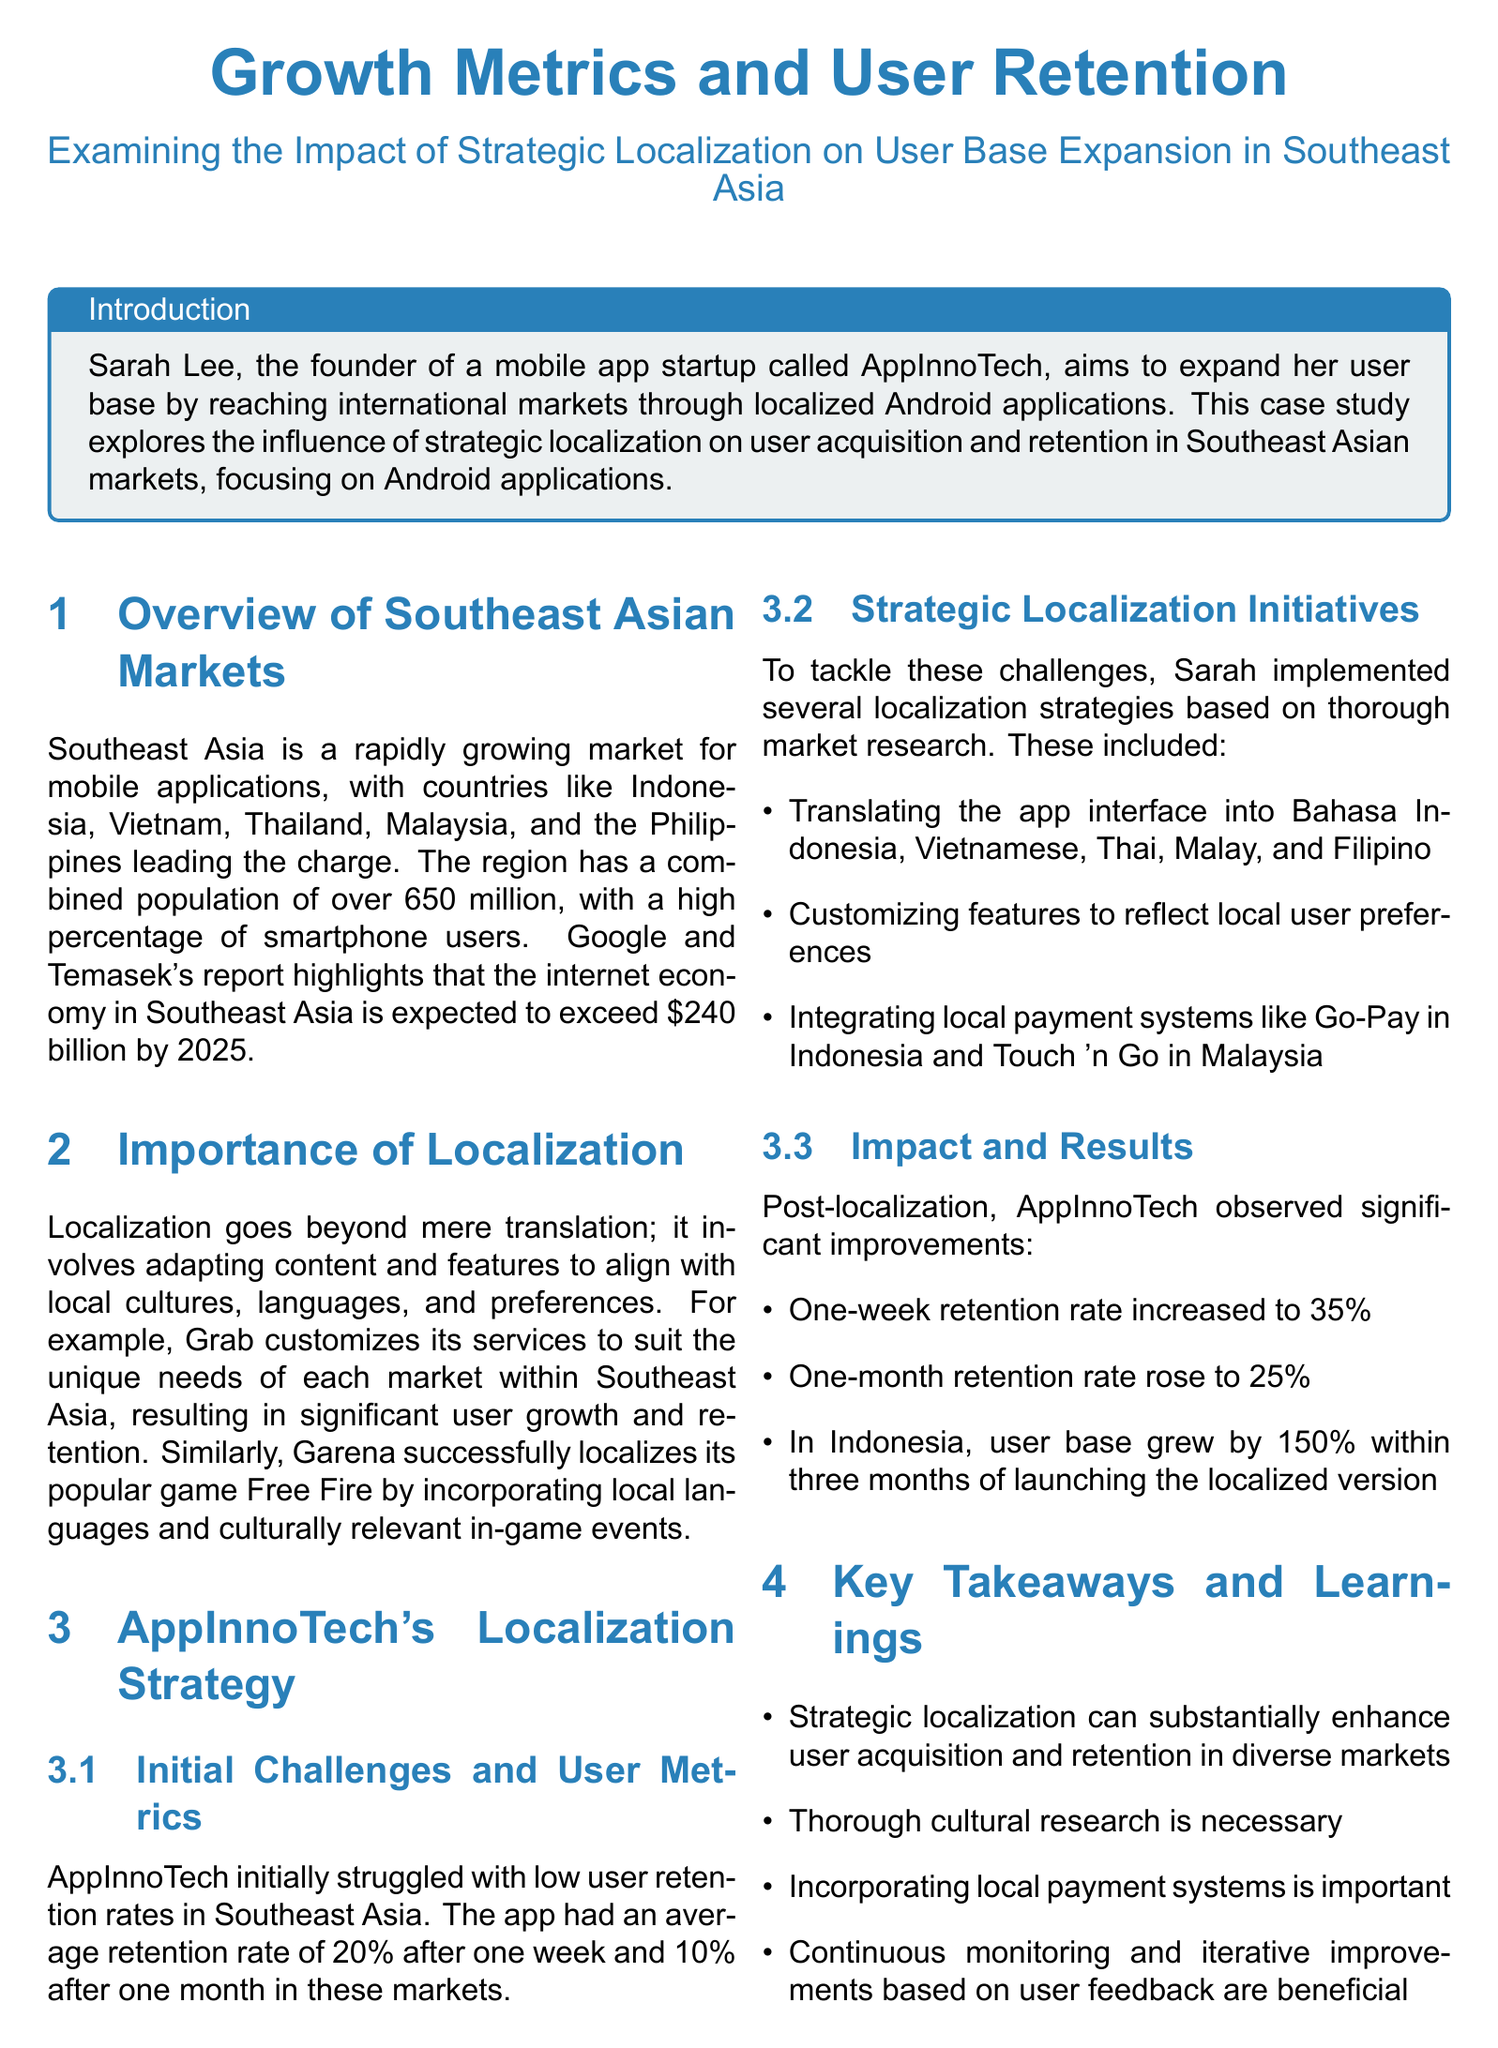what is the average one-week retention rate after localization? The average one-week retention rate post-localization increased from 20% to 35%.
Answer: 35% which countries are highlighted as leaders in the Southeast Asian mobile application market? The case study mentions Indonesia, Vietnam, Thailand, Malaysia, and the Philippines as leaders.
Answer: Indonesia, Vietnam, Thailand, Malaysia, Philippines what percentage did the user base in Indonesia grow within three months of launching the localized version? The user base in Indonesia grew by 150% within three months after localization.
Answer: 150% what was the one-month retention rate before localization? The initial one-month retention rate before localization was 10%.
Answer: 10% which payment systems were integrated as part of the localization strategy? The localization strategy included integrating Go-Pay in Indonesia and Touch 'n Go in Malaysia.
Answer: Go-Pay, Touch 'n Go why is cultural research emphasized in the key takeaways? Cultural research is necessary to effectively tailor the app to local markets for improved retention and growth.
Answer: Necessary for effective localization what role did feature customization play in AppInnoTech's strategy? Feature customization was aimed at reflecting local user preferences to improve retention and acquisition.
Answer: Improve retention and acquisition who is the founder of AppInnoTech? The founder of AppInnoTech is Sarah Lee.
Answer: Sarah Lee 